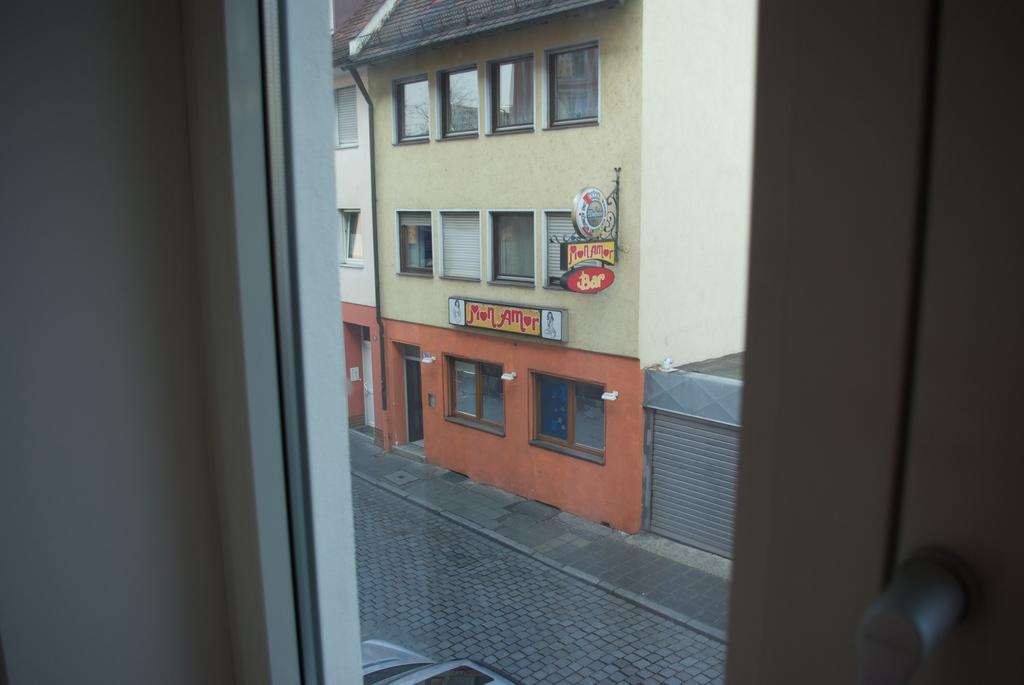What type of structures can be seen in the image? There are buildings visible in the image. What else can be found in the image besides the buildings? There are boards with text in the image. Are there any vehicles present in the image? Yes, there is a car in the image. How many fowl are visible in the image? There are no fowl present in the image. What type of trip is being taken by the people in the image? The image does not show any people or any indication of a trip. 